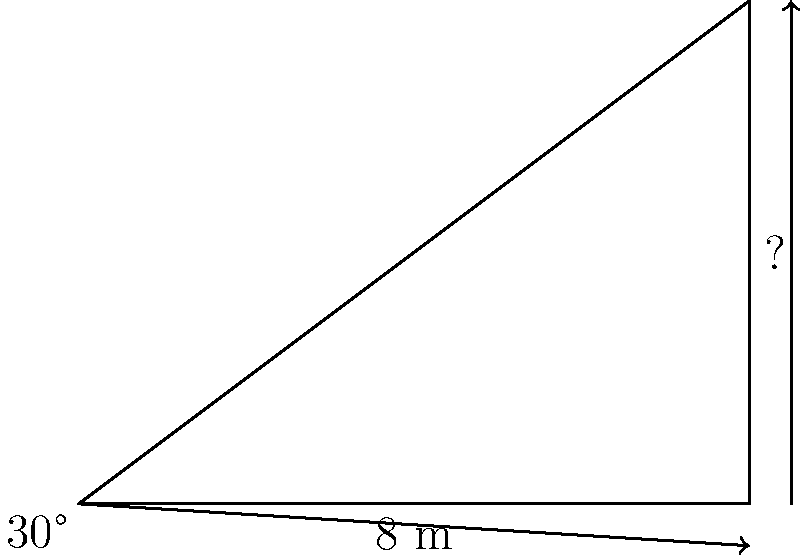As a logistics specialist, you're planning the setup for a concert. You need to determine the height of a stage backdrop. Standing 8 meters away from the base of the backdrop, you measure the angle of elevation to the top of the backdrop to be 30°. What is the height of the backdrop? Let's approach this step-by-step:

1) We can use the tangent function to solve this problem. The tangent of an angle in a right triangle is the ratio of the opposite side to the adjacent side.

2) In this case:
   - The angle is 30°
   - The adjacent side (distance from the observer to the base of the backdrop) is 8 meters
   - We need to find the opposite side (height of the backdrop)

3) Let's set up the equation:
   
   $\tan(30°) = \frac{\text{height}}{\text{distance}}$

4) We know that $\tan(30°) = \frac{1}{\sqrt{3}}$, so we can rewrite the equation:

   $\frac{1}{\sqrt{3}} = \frac{\text{height}}{8}$

5) Cross multiply:

   $8 \cdot \frac{1}{\sqrt{3}} = \text{height}$

6) Simplify:

   $\frac{8}{\sqrt{3}} = \text{height}$

7) To rationalize the denominator, multiply both numerator and denominator by $\sqrt{3}$:

   $\frac{8}{\sqrt{3}} \cdot \frac{\sqrt{3}}{\sqrt{3}} = \frac{8\sqrt{3}}{3} \approx 4.62$ meters

Therefore, the height of the backdrop is $\frac{8\sqrt{3}}{3}$ meters, or approximately 4.62 meters.
Answer: $\frac{8\sqrt{3}}{3}$ meters 